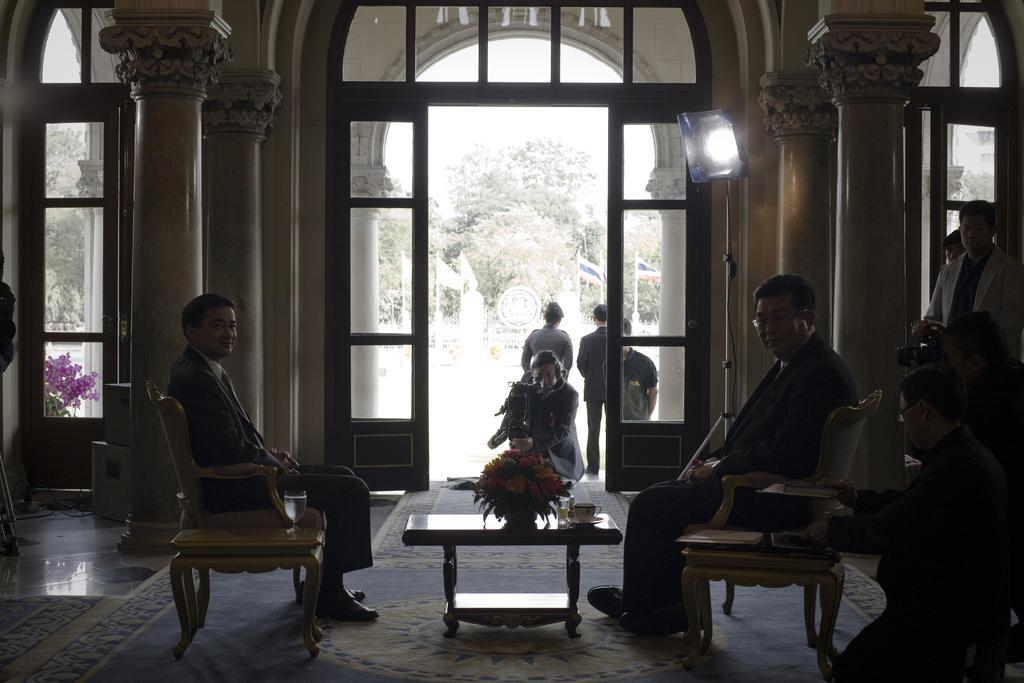Please provide a concise description of this image. Here we can see a person sitting on a chair on the left side and he is smiling. There is a person sitting on a chair on the right side. There are a few people standing on the right side. This is a wooden table where a flower vase and a cup are kept on it. There is a person in the center and he is holding a camera in his hand. Here we can see trees and flags. 